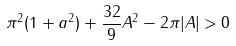Convert formula to latex. <formula><loc_0><loc_0><loc_500><loc_500>\pi ^ { 2 } ( 1 + a ^ { 2 } ) + \frac { 3 2 } { 9 } A ^ { 2 } - 2 \pi | A | > 0</formula> 